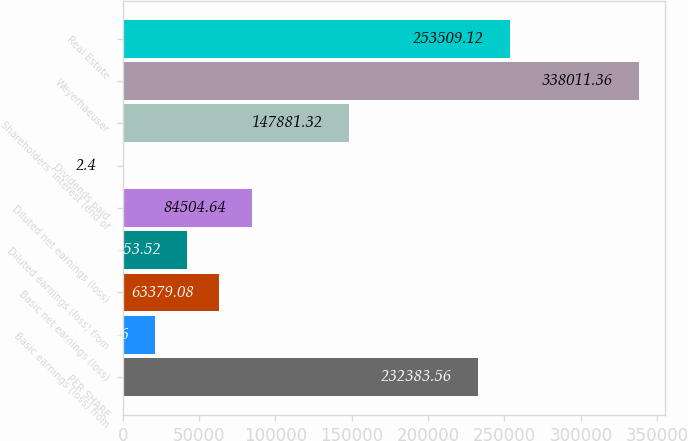Convert chart to OTSL. <chart><loc_0><loc_0><loc_500><loc_500><bar_chart><fcel>PER SHARE<fcel>Basic earnings (loss) from<fcel>Basic net earnings (loss)<fcel>Diluted earnings (loss) from<fcel>Diluted net earnings (loss)<fcel>Dividends paid<fcel>Shareholders' interest (end of<fcel>Weyerhaeuser<fcel>Real Estate<nl><fcel>232384<fcel>21128<fcel>63379.1<fcel>42253.5<fcel>84504.6<fcel>2.4<fcel>147881<fcel>338011<fcel>253509<nl></chart> 